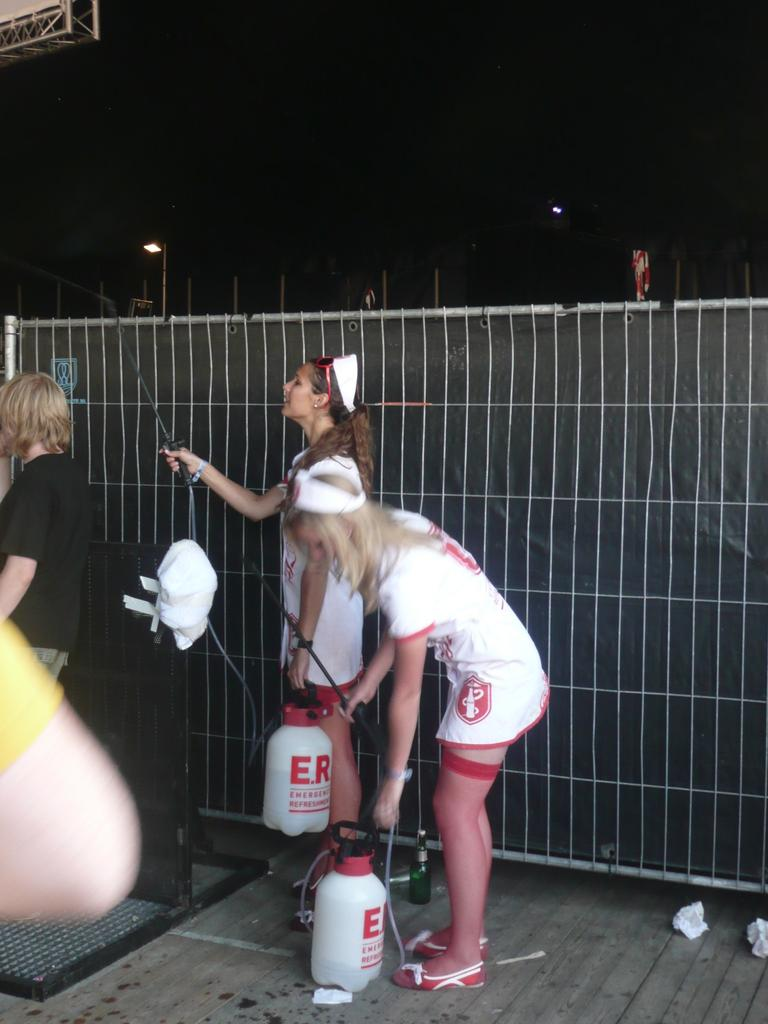<image>
Describe the image concisely. Two girls dressed up as nurses carry spray bottles that say ER on them 